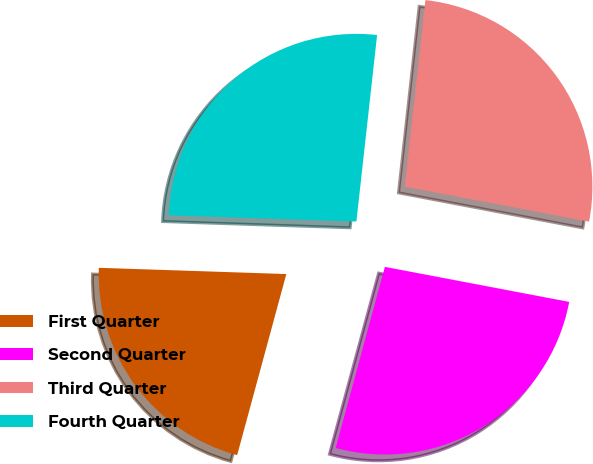Convert chart to OTSL. <chart><loc_0><loc_0><loc_500><loc_500><pie_chart><fcel>First Quarter<fcel>Second Quarter<fcel>Third Quarter<fcel>Fourth Quarter<nl><fcel>21.31%<fcel>26.23%<fcel>26.23%<fcel>26.23%<nl></chart> 